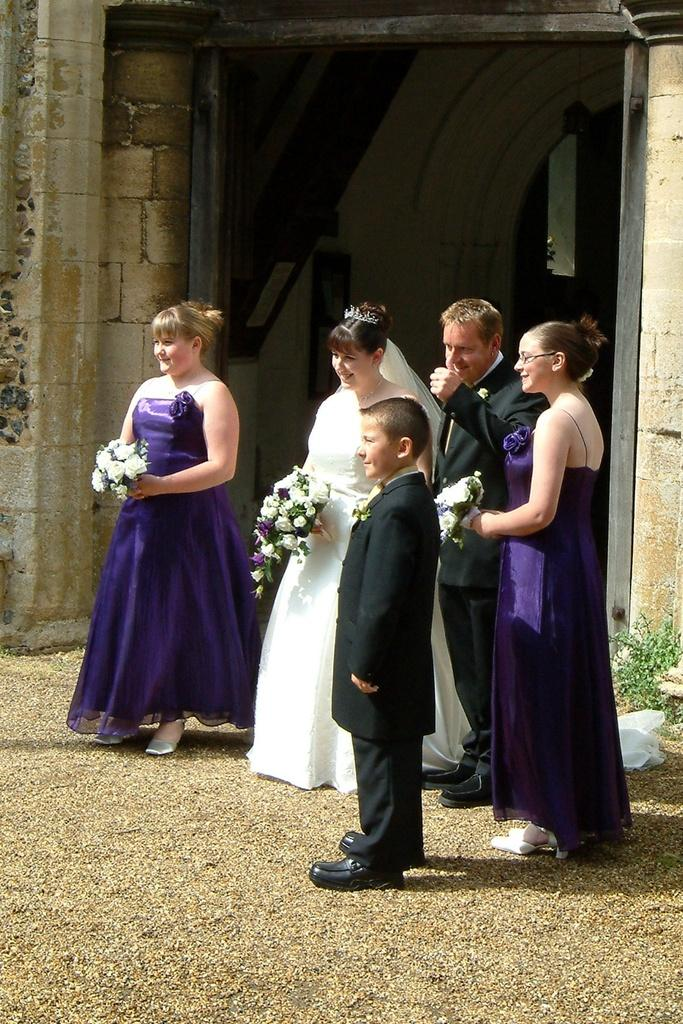What is happening in the image? There are people standing in the image. What are some of the people holding? Some of the people are holding flower bouquets. What can be seen in the background of the image? There are brick walls in the background of the image. What type of silk is draped over the achiever in the image? There is no silk or achiever present in the image. What color is the hydrant located near the people in the image? There is no hydrant present in the image. 